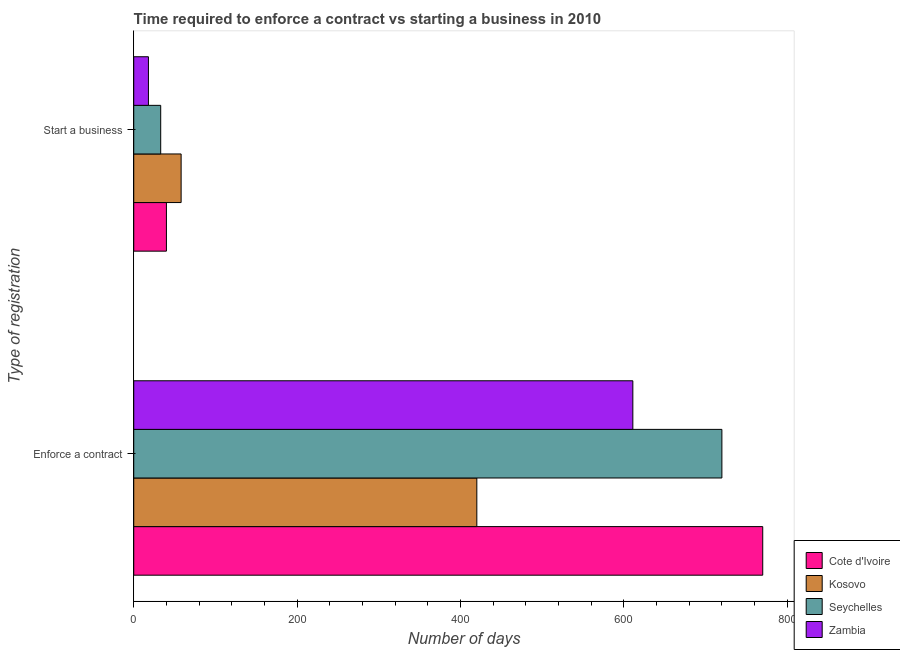How many groups of bars are there?
Ensure brevity in your answer.  2. Are the number of bars per tick equal to the number of legend labels?
Ensure brevity in your answer.  Yes. How many bars are there on the 2nd tick from the top?
Your answer should be very brief. 4. What is the label of the 1st group of bars from the top?
Offer a terse response. Start a business. What is the number of days to enforece a contract in Zambia?
Make the answer very short. 611. Across all countries, what is the maximum number of days to start a business?
Ensure brevity in your answer.  58. Across all countries, what is the minimum number of days to enforece a contract?
Ensure brevity in your answer.  420. In which country was the number of days to start a business maximum?
Offer a very short reply. Kosovo. In which country was the number of days to start a business minimum?
Your response must be concise. Zambia. What is the total number of days to start a business in the graph?
Your answer should be compact. 149. What is the difference between the number of days to start a business in Seychelles and that in Zambia?
Your response must be concise. 15. What is the difference between the number of days to enforece a contract in Zambia and the number of days to start a business in Seychelles?
Your response must be concise. 578. What is the average number of days to enforece a contract per country?
Offer a very short reply. 630.25. What is the difference between the number of days to enforece a contract and number of days to start a business in Seychelles?
Keep it short and to the point. 687. In how many countries, is the number of days to start a business greater than 720 days?
Make the answer very short. 0. What is the ratio of the number of days to start a business in Zambia to that in Kosovo?
Provide a short and direct response. 0.31. Is the number of days to start a business in Cote d'Ivoire less than that in Zambia?
Make the answer very short. No. What does the 3rd bar from the top in Start a business represents?
Ensure brevity in your answer.  Kosovo. What does the 1st bar from the bottom in Enforce a contract represents?
Provide a short and direct response. Cote d'Ivoire. Are the values on the major ticks of X-axis written in scientific E-notation?
Your answer should be compact. No. Does the graph contain grids?
Keep it short and to the point. No. Where does the legend appear in the graph?
Your answer should be very brief. Bottom right. How many legend labels are there?
Ensure brevity in your answer.  4. What is the title of the graph?
Offer a very short reply. Time required to enforce a contract vs starting a business in 2010. Does "Chile" appear as one of the legend labels in the graph?
Your answer should be very brief. No. What is the label or title of the X-axis?
Ensure brevity in your answer.  Number of days. What is the label or title of the Y-axis?
Offer a very short reply. Type of registration. What is the Number of days in Cote d'Ivoire in Enforce a contract?
Ensure brevity in your answer.  770. What is the Number of days of Kosovo in Enforce a contract?
Provide a short and direct response. 420. What is the Number of days of Seychelles in Enforce a contract?
Offer a very short reply. 720. What is the Number of days of Zambia in Enforce a contract?
Give a very brief answer. 611. What is the Number of days in Cote d'Ivoire in Start a business?
Your response must be concise. 40. What is the Number of days in Kosovo in Start a business?
Keep it short and to the point. 58. What is the Number of days of Seychelles in Start a business?
Ensure brevity in your answer.  33. Across all Type of registration, what is the maximum Number of days in Cote d'Ivoire?
Your answer should be very brief. 770. Across all Type of registration, what is the maximum Number of days in Kosovo?
Provide a succinct answer. 420. Across all Type of registration, what is the maximum Number of days in Seychelles?
Ensure brevity in your answer.  720. Across all Type of registration, what is the maximum Number of days of Zambia?
Make the answer very short. 611. Across all Type of registration, what is the minimum Number of days in Cote d'Ivoire?
Ensure brevity in your answer.  40. What is the total Number of days in Cote d'Ivoire in the graph?
Your response must be concise. 810. What is the total Number of days of Kosovo in the graph?
Offer a terse response. 478. What is the total Number of days in Seychelles in the graph?
Your response must be concise. 753. What is the total Number of days of Zambia in the graph?
Ensure brevity in your answer.  629. What is the difference between the Number of days in Cote d'Ivoire in Enforce a contract and that in Start a business?
Offer a terse response. 730. What is the difference between the Number of days in Kosovo in Enforce a contract and that in Start a business?
Give a very brief answer. 362. What is the difference between the Number of days in Seychelles in Enforce a contract and that in Start a business?
Provide a short and direct response. 687. What is the difference between the Number of days in Zambia in Enforce a contract and that in Start a business?
Give a very brief answer. 593. What is the difference between the Number of days in Cote d'Ivoire in Enforce a contract and the Number of days in Kosovo in Start a business?
Give a very brief answer. 712. What is the difference between the Number of days in Cote d'Ivoire in Enforce a contract and the Number of days in Seychelles in Start a business?
Offer a terse response. 737. What is the difference between the Number of days of Cote d'Ivoire in Enforce a contract and the Number of days of Zambia in Start a business?
Ensure brevity in your answer.  752. What is the difference between the Number of days in Kosovo in Enforce a contract and the Number of days in Seychelles in Start a business?
Offer a very short reply. 387. What is the difference between the Number of days in Kosovo in Enforce a contract and the Number of days in Zambia in Start a business?
Ensure brevity in your answer.  402. What is the difference between the Number of days in Seychelles in Enforce a contract and the Number of days in Zambia in Start a business?
Your response must be concise. 702. What is the average Number of days of Cote d'Ivoire per Type of registration?
Your answer should be very brief. 405. What is the average Number of days in Kosovo per Type of registration?
Your answer should be compact. 239. What is the average Number of days in Seychelles per Type of registration?
Your response must be concise. 376.5. What is the average Number of days of Zambia per Type of registration?
Your response must be concise. 314.5. What is the difference between the Number of days of Cote d'Ivoire and Number of days of Kosovo in Enforce a contract?
Your response must be concise. 350. What is the difference between the Number of days in Cote d'Ivoire and Number of days in Zambia in Enforce a contract?
Offer a very short reply. 159. What is the difference between the Number of days in Kosovo and Number of days in Seychelles in Enforce a contract?
Offer a very short reply. -300. What is the difference between the Number of days of Kosovo and Number of days of Zambia in Enforce a contract?
Provide a short and direct response. -191. What is the difference between the Number of days in Seychelles and Number of days in Zambia in Enforce a contract?
Keep it short and to the point. 109. What is the difference between the Number of days in Cote d'Ivoire and Number of days in Kosovo in Start a business?
Provide a short and direct response. -18. What is the difference between the Number of days in Cote d'Ivoire and Number of days in Seychelles in Start a business?
Your answer should be very brief. 7. What is the difference between the Number of days in Cote d'Ivoire and Number of days in Zambia in Start a business?
Your answer should be very brief. 22. What is the difference between the Number of days in Kosovo and Number of days in Zambia in Start a business?
Offer a very short reply. 40. What is the ratio of the Number of days of Cote d'Ivoire in Enforce a contract to that in Start a business?
Provide a short and direct response. 19.25. What is the ratio of the Number of days in Kosovo in Enforce a contract to that in Start a business?
Your answer should be compact. 7.24. What is the ratio of the Number of days in Seychelles in Enforce a contract to that in Start a business?
Give a very brief answer. 21.82. What is the ratio of the Number of days of Zambia in Enforce a contract to that in Start a business?
Offer a very short reply. 33.94. What is the difference between the highest and the second highest Number of days of Cote d'Ivoire?
Give a very brief answer. 730. What is the difference between the highest and the second highest Number of days of Kosovo?
Your answer should be compact. 362. What is the difference between the highest and the second highest Number of days of Seychelles?
Ensure brevity in your answer.  687. What is the difference between the highest and the second highest Number of days in Zambia?
Keep it short and to the point. 593. What is the difference between the highest and the lowest Number of days in Cote d'Ivoire?
Your answer should be compact. 730. What is the difference between the highest and the lowest Number of days in Kosovo?
Offer a very short reply. 362. What is the difference between the highest and the lowest Number of days of Seychelles?
Your response must be concise. 687. What is the difference between the highest and the lowest Number of days of Zambia?
Offer a terse response. 593. 